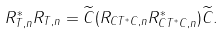Convert formula to latex. <formula><loc_0><loc_0><loc_500><loc_500>R _ { T , n } ^ { * } R _ { T , n } = \widetilde { C } ( R _ { C T ^ { * } C , n } R _ { C T ^ { * } C , n } ^ { * } ) \widetilde { C } .</formula> 